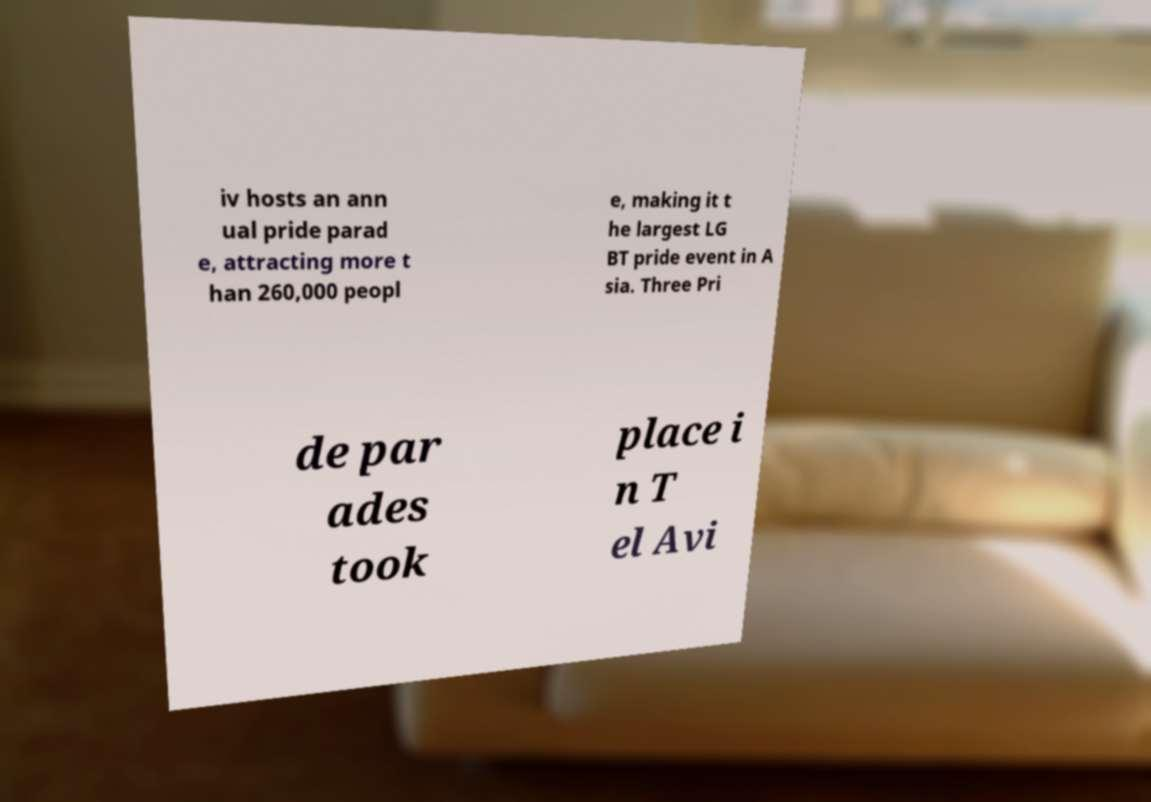Could you extract and type out the text from this image? iv hosts an ann ual pride parad e, attracting more t han 260,000 peopl e, making it t he largest LG BT pride event in A sia. Three Pri de par ades took place i n T el Avi 